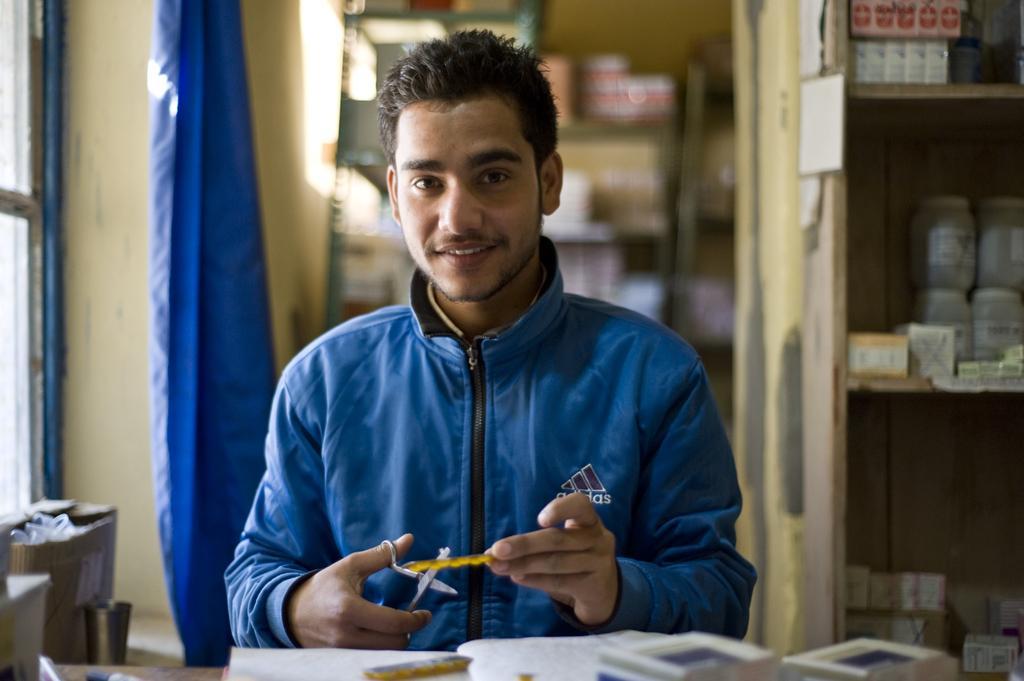Describe this image in one or two sentences. In this picture there is a man who is wearing a blue jacket. He is holding a scissor in his hand. There are few bottles in the shelf. There is a box and a bucket on the floor. 